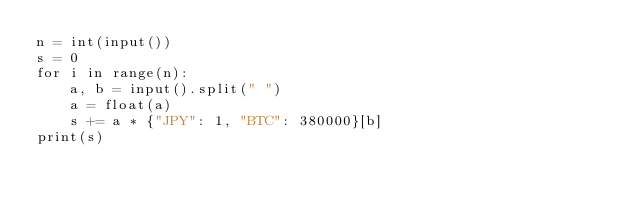Convert code to text. <code><loc_0><loc_0><loc_500><loc_500><_Python_>n = int(input())
s = 0
for i in range(n):
    a, b = input().split(" ")
    a = float(a)
    s += a * {"JPY": 1, "BTC": 380000}[b]
print(s)
</code> 